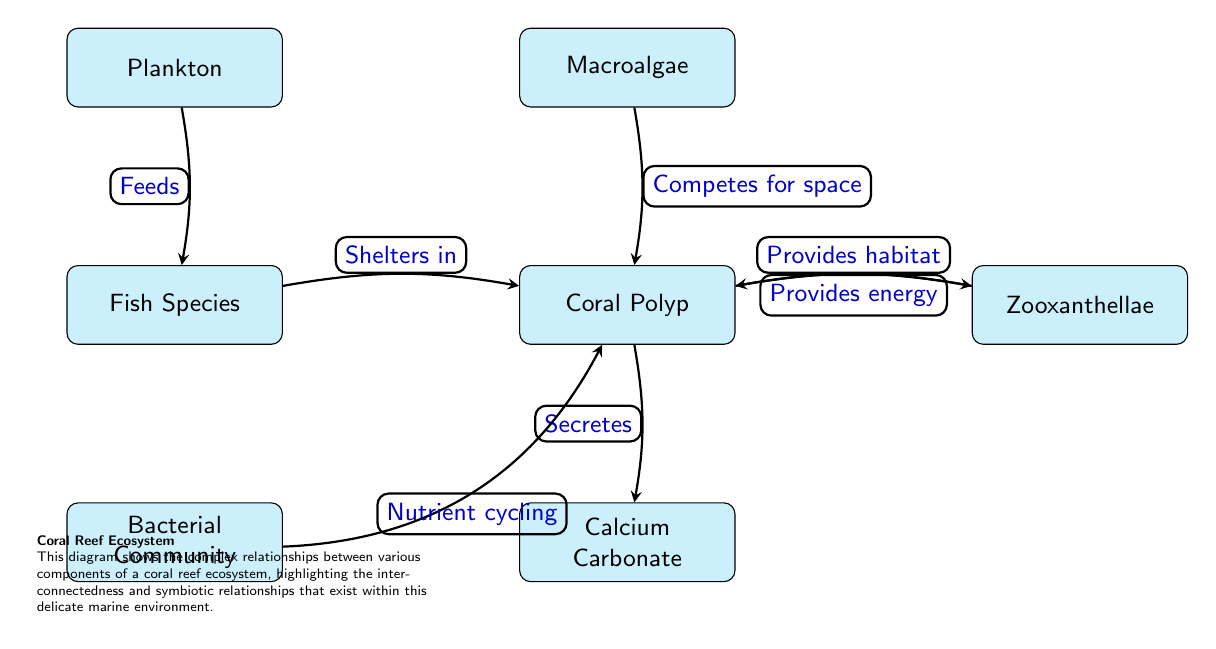What is the role of zooxanthellae in the coral polyp's ecosystem? The relationship between coral polyps and zooxanthellae is two-way: zooxanthellae provide energy to coral polyps through photosynthesis, while coral polyps provide habitat for the zooxanthellae.
Answer: Energy What do corals secrete? The diagram indicates that corals secrete calcium carbonate, emphasizing their role in building the reef structure.
Answer: Calcium carbonate How many relationships are represented in the diagram? By counting the arrows connecting the nodes, there are six distinct relationships in the diagram that illustrate the interactions within the ecosystem.
Answer: Six Which organisms feed on plankton? The fish species in the diagram have a direct link that demonstrates they feed on plankton, capturing the trophic interaction in the coral reef ecosystem.
Answer: Fish species What relationship exists between bacteria and coral? The bacteria community is illustrated as participating in nutrient cycling for the corals, showcasing a symbiotic relationship that benefits the ecosystem's health.
Answer: Nutrient cycling How do macroalgae interact with coral? The arrow from macroalgae to coral indicates that macroalgae competes for space with coral, demonstrating a competitive relationship that can affect coral growth and health.
Answer: Competes for space What is the significance of the coral polyp in this ecosystem? The coral polyp acts as a central hub, providing habitat for several organisms, while also being involved in energy exchange and structural formation, highlighting its key role in the reef ecosystem.
Answer: Habitat What is the function of calcium carbonate in the reef? Calcium carbonate serves as the foundation for coral reefs, providing structural support essential for various marine life, underscoring its importance in reef-building.
Answer: Structural support What connects the relationship between fish species and coral? The fish species shelter in the coral, making a direct connection that shows how coral provides safety and habitat for these organisms within the marine environment.
Answer: Shelters in 